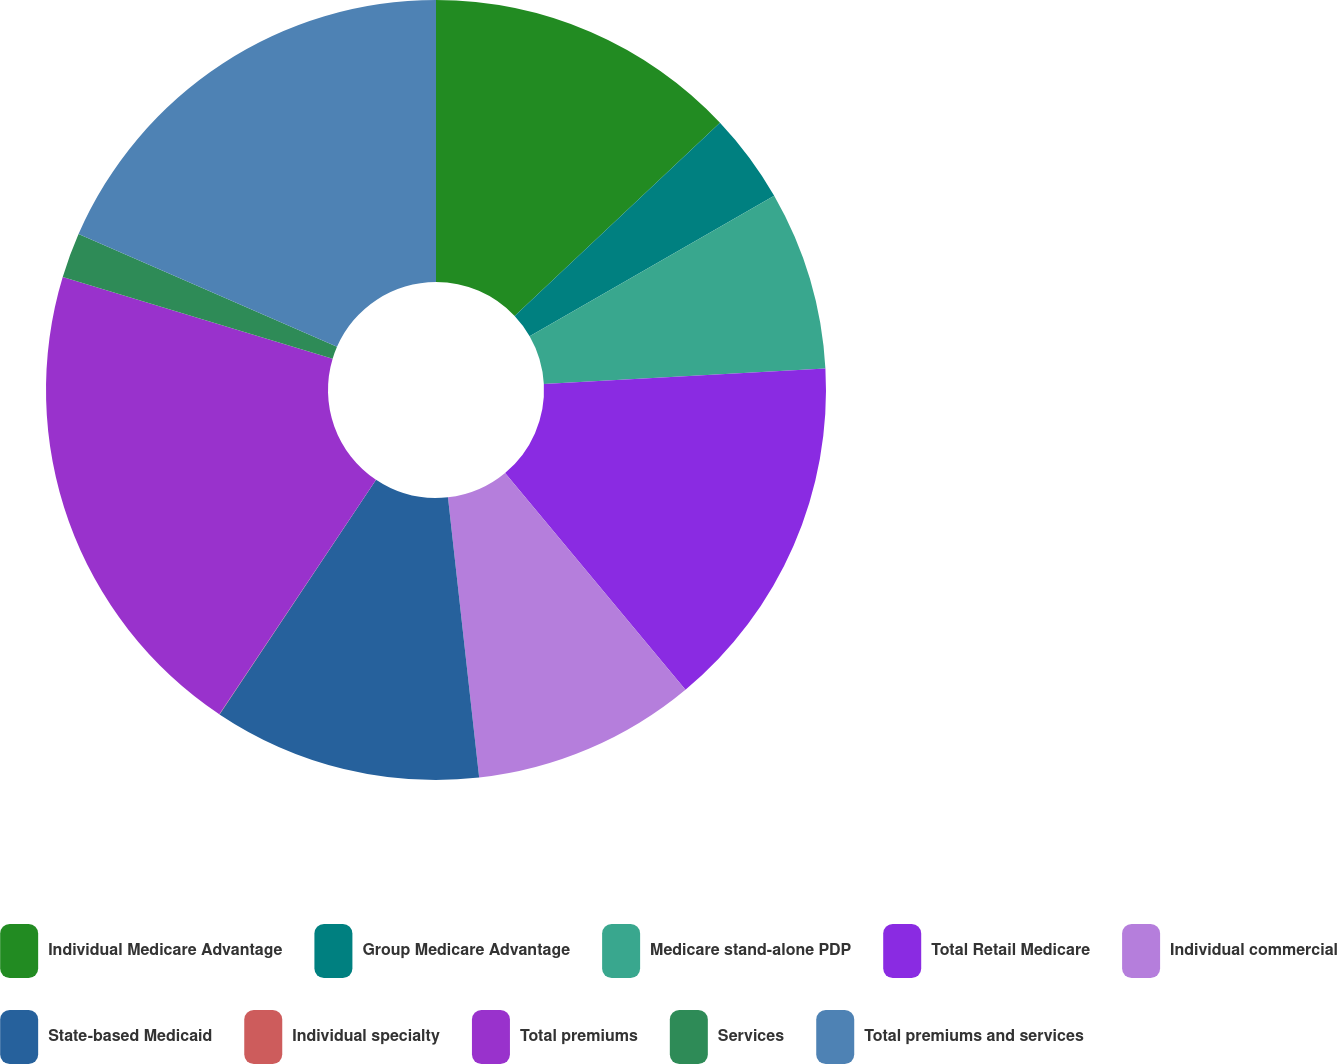Convert chart to OTSL. <chart><loc_0><loc_0><loc_500><loc_500><pie_chart><fcel>Individual Medicare Advantage<fcel>Group Medicare Advantage<fcel>Medicare stand-alone PDP<fcel>Total Retail Medicare<fcel>Individual commercial<fcel>State-based Medicaid<fcel>Individual specialty<fcel>Total premiums<fcel>Services<fcel>Total premiums and services<nl><fcel>12.98%<fcel>3.72%<fcel>7.42%<fcel>14.83%<fcel>9.28%<fcel>11.13%<fcel>0.01%<fcel>20.3%<fcel>1.87%<fcel>18.45%<nl></chart> 